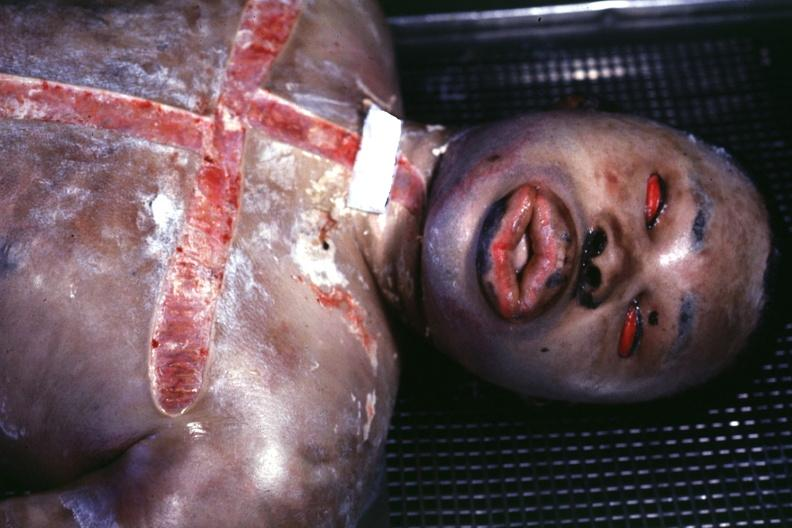where is this?
Answer the question using a single word or phrase. Skin 